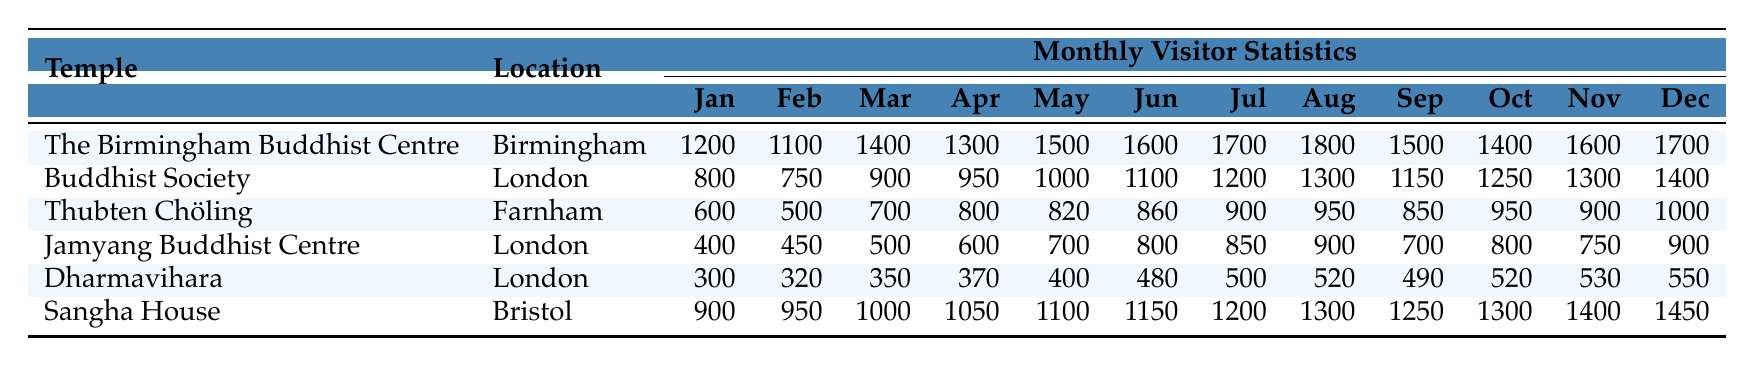What is the total number of visitors to The Birmingham Buddhist Centre in the month of July? Looking at the table, the number of visitors to The Birmingham Buddhist Centre in July is 1700.
Answer: 1700 Which temple had the highest number of visitors in August? In August, The Birmingham Buddhist Centre had 1800 visitors, which is more than any other temple listed.
Answer: The Birmingham Buddhist Centre What is the visitor count for Jamyang Buddhist Centre in December? The table shows that Jamyang Buddhist Centre had 900 visitors in December.
Answer: 900 How many visitors did Dharmavihara have in April? The visitor count for Dharmavihara in April is listed as 370 in the table.
Answer: 370 What is the average number of visitors per month for the Buddhist Society? To find the average, sum the monthly visitors: (800 + 750 + 900 + 950 + 1000 + 1100 + 1200 + 1300 + 1150 + 1250 + 1300 + 1400) = 13300. Divide this by 12 months to get the average: 13300 / 12 = 1108.33, which can be rounded to 1108.
Answer: 1108 Does Thubten Chöling have more visitors in June or September? The table shows Thubten Chöling had 860 visitors in June and 850 visitors in September. Therefore, it had more visitors in June.
Answer: Yes What is the change in visitor numbers for Sangha House from January to December? Sangha House had 900 visitors in January and 1450 in December. The change is 1450 - 900 = 550 visitors.
Answer: 550 Which temple has the least number of visitors in March, and how many were there? Looking at the March visitor counts, Jamyang Buddhist Centre has the least with 500 visitors.
Answer: Jamyang Buddhist Centre, 500 Calculate the total number of visitors across all months for The Birmingham Buddhist Centre. Adding up the monthly visitors: (1200 + 1100 + 1400 + 1300 + 1500 + 1600 + 1700 + 1800 + 1500 + 1400 + 1600 + 1700) = 18900.
Answer: 18900 Which temple had the most consistent visitor numbers throughout the months? To determine consistency, look for the smallest variation in visitor counts across months. Dharmavihara has the least variation, ranging from 300 to 550.
Answer: Dharmavihara 